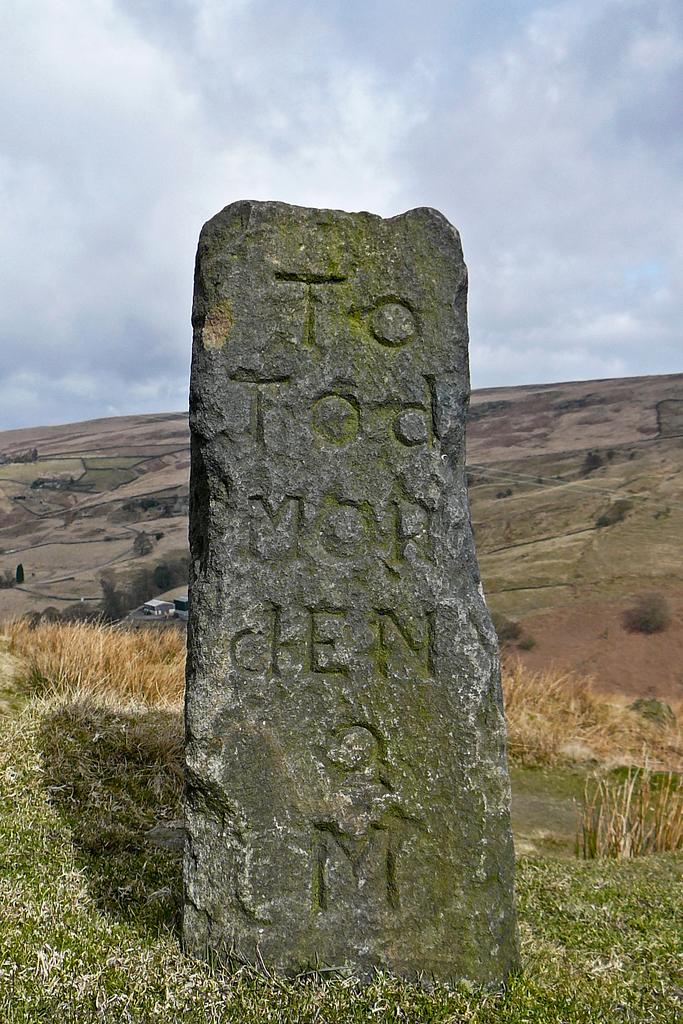What is the main subject in the center of the image? There is a large stone in the center of the image. What can be seen in the background of the image? There is a hill and the sky visible in the background of the image. What type of vegetation is present at the bottom of the image? There is grass at the bottom of the image. How many friends are sitting on the large stone in the image? There are no friends present in the image; it only features a large stone. What time of day is depicted in the image? The time of day cannot be determined from the image, as there is no information about lighting or shadows. 